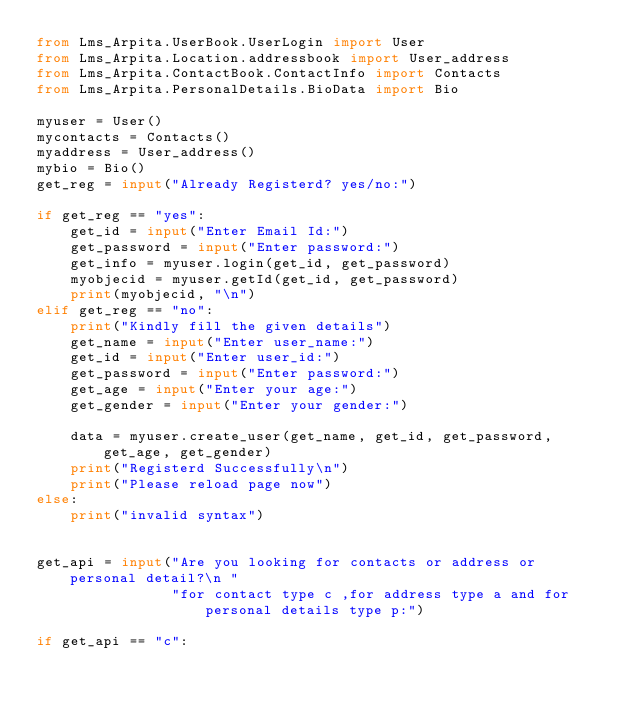Convert code to text. <code><loc_0><loc_0><loc_500><loc_500><_Python_>from Lms_Arpita.UserBook.UserLogin import User
from Lms_Arpita.Location.addressbook import User_address
from Lms_Arpita.ContactBook.ContactInfo import Contacts
from Lms_Arpita.PersonalDetails.BioData import Bio

myuser = User()
mycontacts = Contacts()
myaddress = User_address()
mybio = Bio()
get_reg = input("Already Registerd? yes/no:")

if get_reg == "yes":
    get_id = input("Enter Email Id:")
    get_password = input("Enter password:")
    get_info = myuser.login(get_id, get_password)
    myobjecid = myuser.getId(get_id, get_password)
    print(myobjecid, "\n")
elif get_reg == "no":
    print("Kindly fill the given details")
    get_name = input("Enter user_name:")
    get_id = input("Enter user_id:")
    get_password = input("Enter password:")
    get_age = input("Enter your age:")
    get_gender = input("Enter your gender:")

    data = myuser.create_user(get_name, get_id, get_password, get_age, get_gender)
    print("Registerd Successfully\n")
    print("Please reload page now")
else:
    print("invalid syntax")


get_api = input("Are you looking for contacts or address or personal detail?\n "
                "for contact type c ,for address type a and for personal details type p:")

if get_api == "c":</code> 